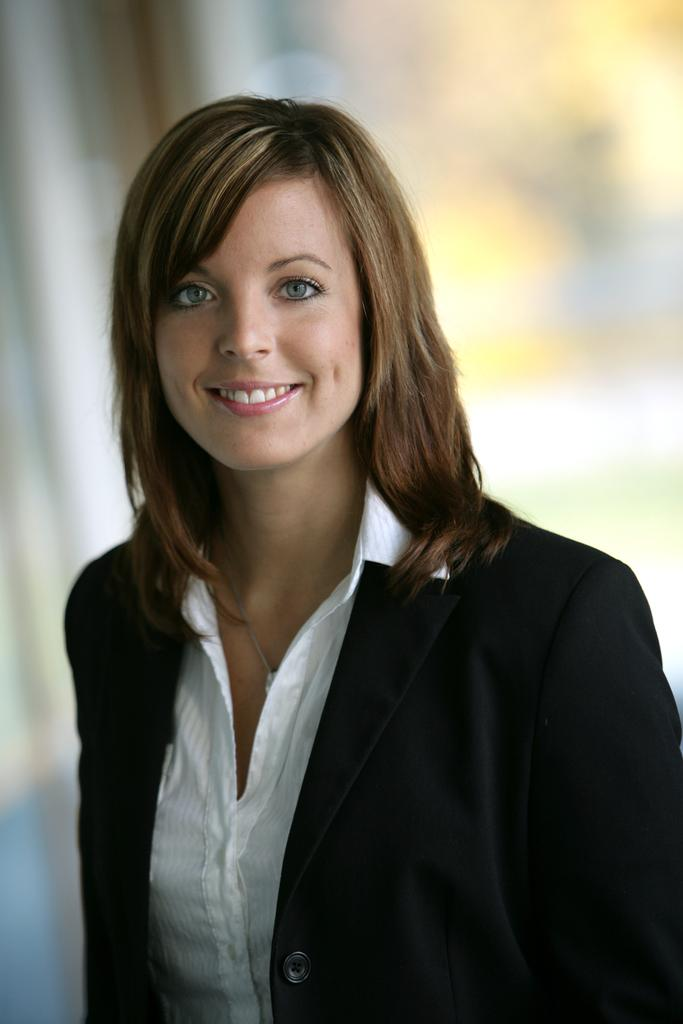What is the main subject in the foreground of the image? There is a woman in the foreground of the image. What is the woman wearing? The woman is wearing a black color blazer. What is the woman's facial expression? The woman is smiling. How is the woman positioned in the image? The woman appears to be standing. How would you describe the background of the image? The background of the image is blurry. What type of bubble can be seen in the image? There is no bubble present in the image. Is the scene taking place during the night in the image? The image does not provide any information about the time of day, so it cannot be determined if it is night or not. 